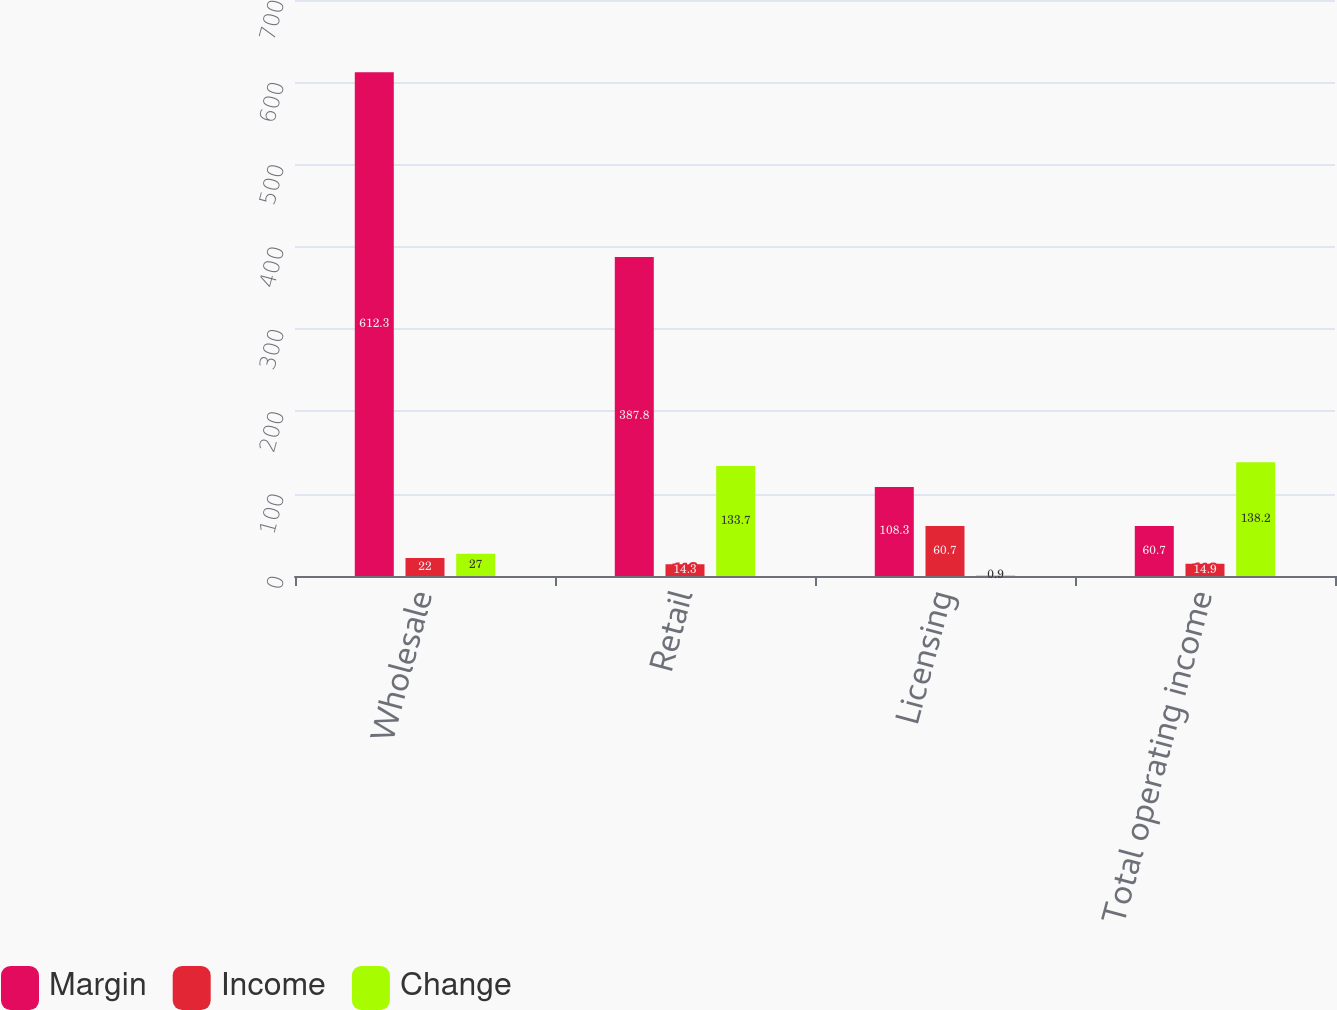Convert chart. <chart><loc_0><loc_0><loc_500><loc_500><stacked_bar_chart><ecel><fcel>Wholesale<fcel>Retail<fcel>Licensing<fcel>Total operating income<nl><fcel>Margin<fcel>612.3<fcel>387.8<fcel>108.3<fcel>60.7<nl><fcel>Income<fcel>22<fcel>14.3<fcel>60.7<fcel>14.9<nl><fcel>Change<fcel>27<fcel>133.7<fcel>0.9<fcel>138.2<nl></chart> 